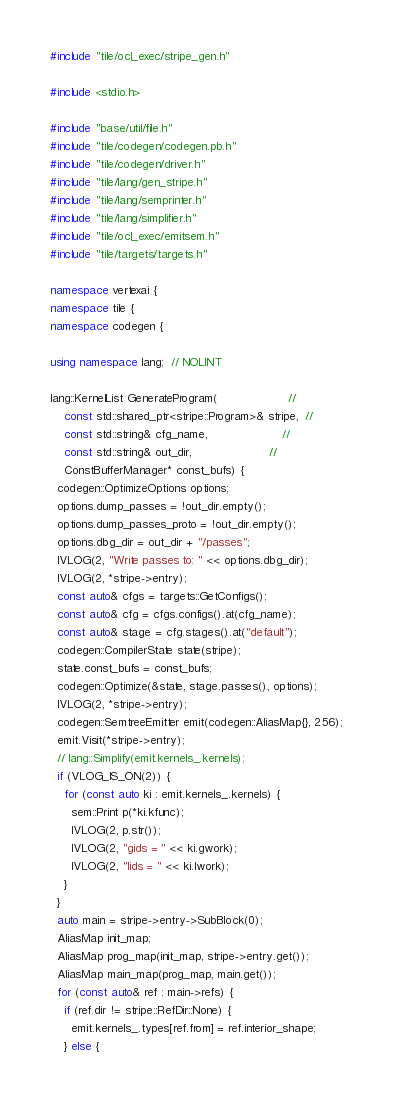Convert code to text. <code><loc_0><loc_0><loc_500><loc_500><_C++_>#include "tile/ocl_exec/stripe_gen.h"

#include <stdio.h>

#include "base/util/file.h"
#include "tile/codegen/codegen.pb.h"
#include "tile/codegen/driver.h"
#include "tile/lang/gen_stripe.h"
#include "tile/lang/semprinter.h"
#include "tile/lang/simplifier.h"
#include "tile/ocl_exec/emitsem.h"
#include "tile/targets/targets.h"

namespace vertexai {
namespace tile {
namespace codegen {

using namespace lang;  // NOLINT

lang::KernelList GenerateProgram(                    //
    const std::shared_ptr<stripe::Program>& stripe,  //
    const std::string& cfg_name,                     //
    const std::string& out_dir,                      //
    ConstBufferManager* const_bufs) {
  codegen::OptimizeOptions options;
  options.dump_passes = !out_dir.empty();
  options.dump_passes_proto = !out_dir.empty();
  options.dbg_dir = out_dir + "/passes";
  IVLOG(2, "Write passes to: " << options.dbg_dir);
  IVLOG(2, *stripe->entry);
  const auto& cfgs = targets::GetConfigs();
  const auto& cfg = cfgs.configs().at(cfg_name);
  const auto& stage = cfg.stages().at("default");
  codegen::CompilerState state(stripe);
  state.const_bufs = const_bufs;
  codegen::Optimize(&state, stage.passes(), options);
  IVLOG(2, *stripe->entry);
  codegen::SemtreeEmitter emit(codegen::AliasMap{}, 256);
  emit.Visit(*stripe->entry);
  // lang::Simplify(emit.kernels_.kernels);
  if (VLOG_IS_ON(2)) {
    for (const auto ki : emit.kernels_.kernels) {
      sem::Print p(*ki.kfunc);
      IVLOG(2, p.str());
      IVLOG(2, "gids = " << ki.gwork);
      IVLOG(2, "lids = " << ki.lwork);
    }
  }
  auto main = stripe->entry->SubBlock(0);
  AliasMap init_map;
  AliasMap prog_map(init_map, stripe->entry.get());
  AliasMap main_map(prog_map, main.get());
  for (const auto& ref : main->refs) {
    if (ref.dir != stripe::RefDir::None) {
      emit.kernels_.types[ref.from] = ref.interior_shape;
    } else {</code> 